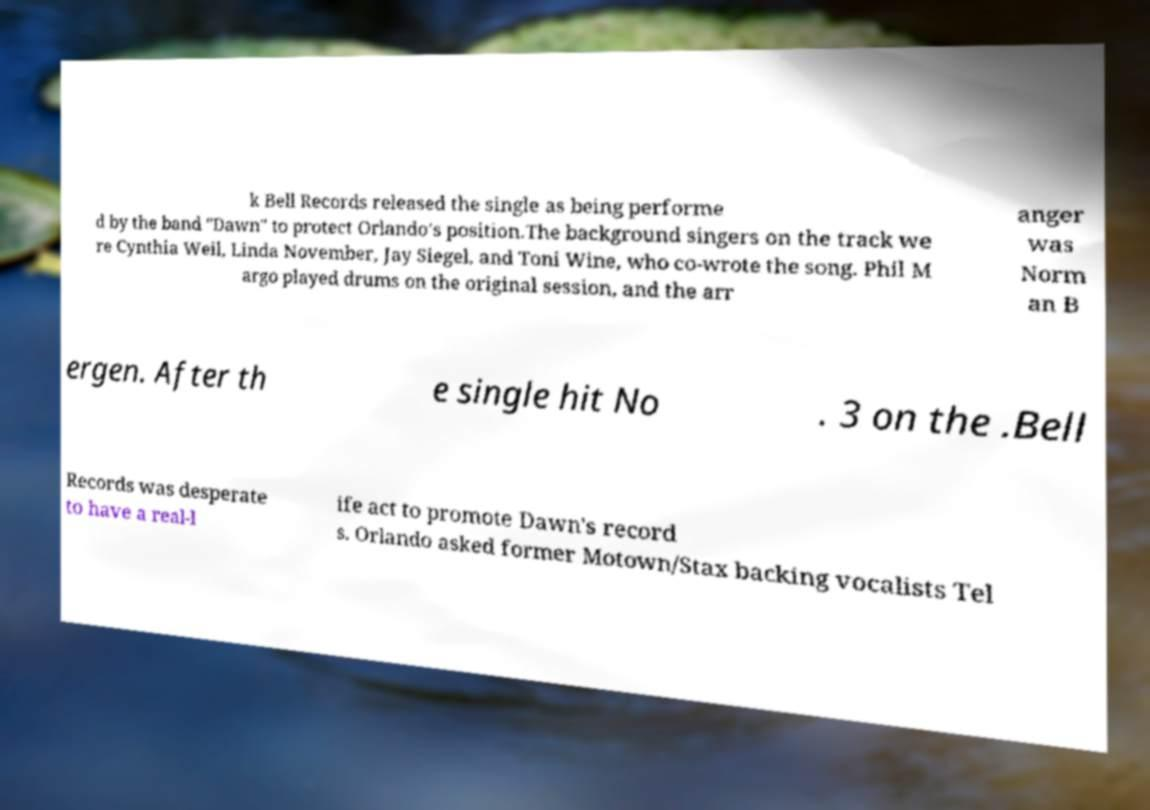There's text embedded in this image that I need extracted. Can you transcribe it verbatim? k Bell Records released the single as being performe d by the band "Dawn" to protect Orlando's position.The background singers on the track we re Cynthia Weil, Linda November, Jay Siegel, and Toni Wine, who co-wrote the song. Phil M argo played drums on the original session, and the arr anger was Norm an B ergen. After th e single hit No . 3 on the .Bell Records was desperate to have a real-l ife act to promote Dawn's record s. Orlando asked former Motown/Stax backing vocalists Tel 